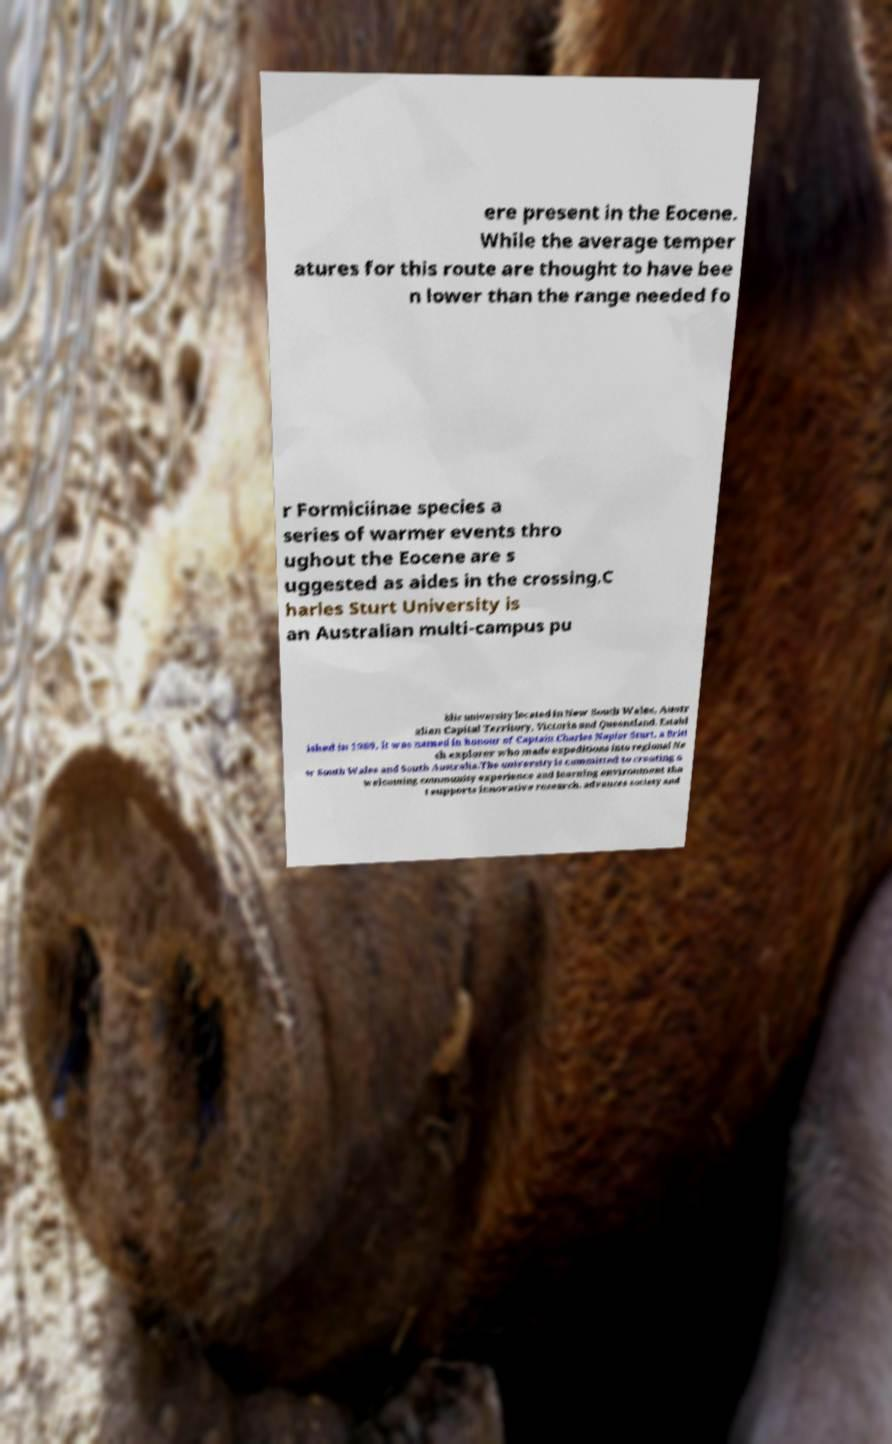What messages or text are displayed in this image? I need them in a readable, typed format. ere present in the Eocene. While the average temper atures for this route are thought to have bee n lower than the range needed fo r Formiciinae species a series of warmer events thro ughout the Eocene are s uggested as aides in the crossing.C harles Sturt University is an Australian multi-campus pu blic university located in New South Wales, Austr alian Capital Territory, Victoria and Queensland. Establ ished in 1989, it was named in honour of Captain Charles Napier Sturt, a Briti sh explorer who made expeditions into regional Ne w South Wales and South Australia.The university is committed to creating a welcoming community experience and learning environment tha t supports innovative research, advances society and 